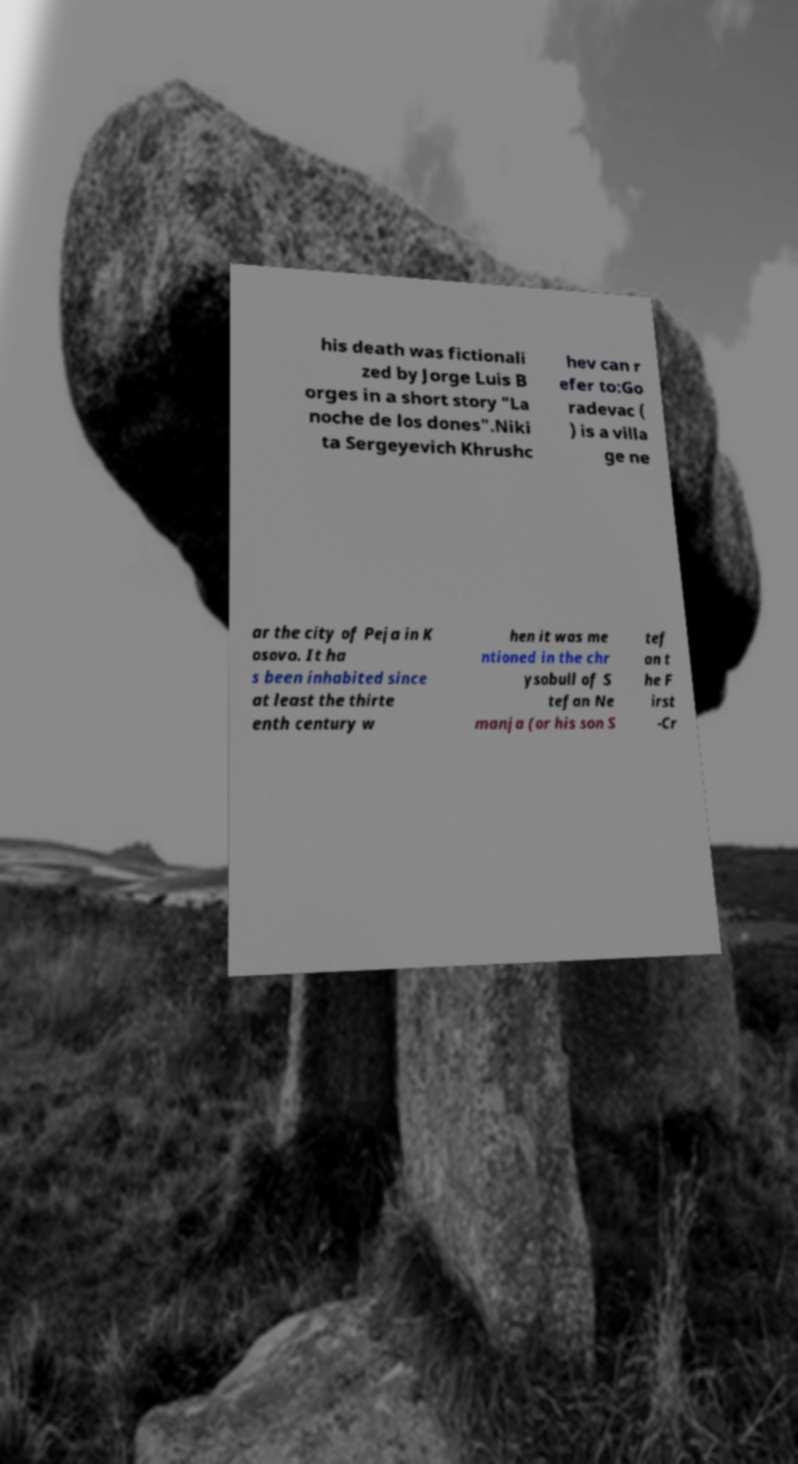Please read and relay the text visible in this image. What does it say? his death was fictionali zed by Jorge Luis B orges in a short story "La noche de los dones".Niki ta Sergeyevich Khrushc hev can r efer to:Go radevac ( ) is a villa ge ne ar the city of Peja in K osovo. It ha s been inhabited since at least the thirte enth century w hen it was me ntioned in the chr ysobull of S tefan Ne manja (or his son S tef an t he F irst -Cr 